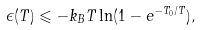<formula> <loc_0><loc_0><loc_500><loc_500>\epsilon ( T ) \leqslant - k _ { B } T \ln ( 1 - e ^ { - T _ { 0 } / T } ) ,</formula> 